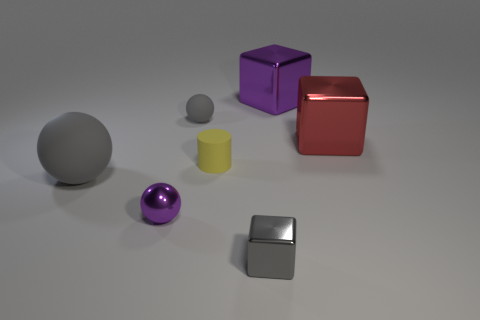Subtract all big shiny cubes. How many cubes are left? 1 Subtract all yellow cylinders. How many gray balls are left? 2 Subtract all gray balls. How many balls are left? 1 Subtract 1 blocks. How many blocks are left? 2 Subtract all cubes. How many objects are left? 4 Add 1 large gray matte objects. How many objects exist? 8 Subtract all cyan spheres. Subtract all green cylinders. How many spheres are left? 3 Subtract 1 red blocks. How many objects are left? 6 Subtract all tiny yellow matte cylinders. Subtract all large objects. How many objects are left? 3 Add 3 big spheres. How many big spheres are left? 4 